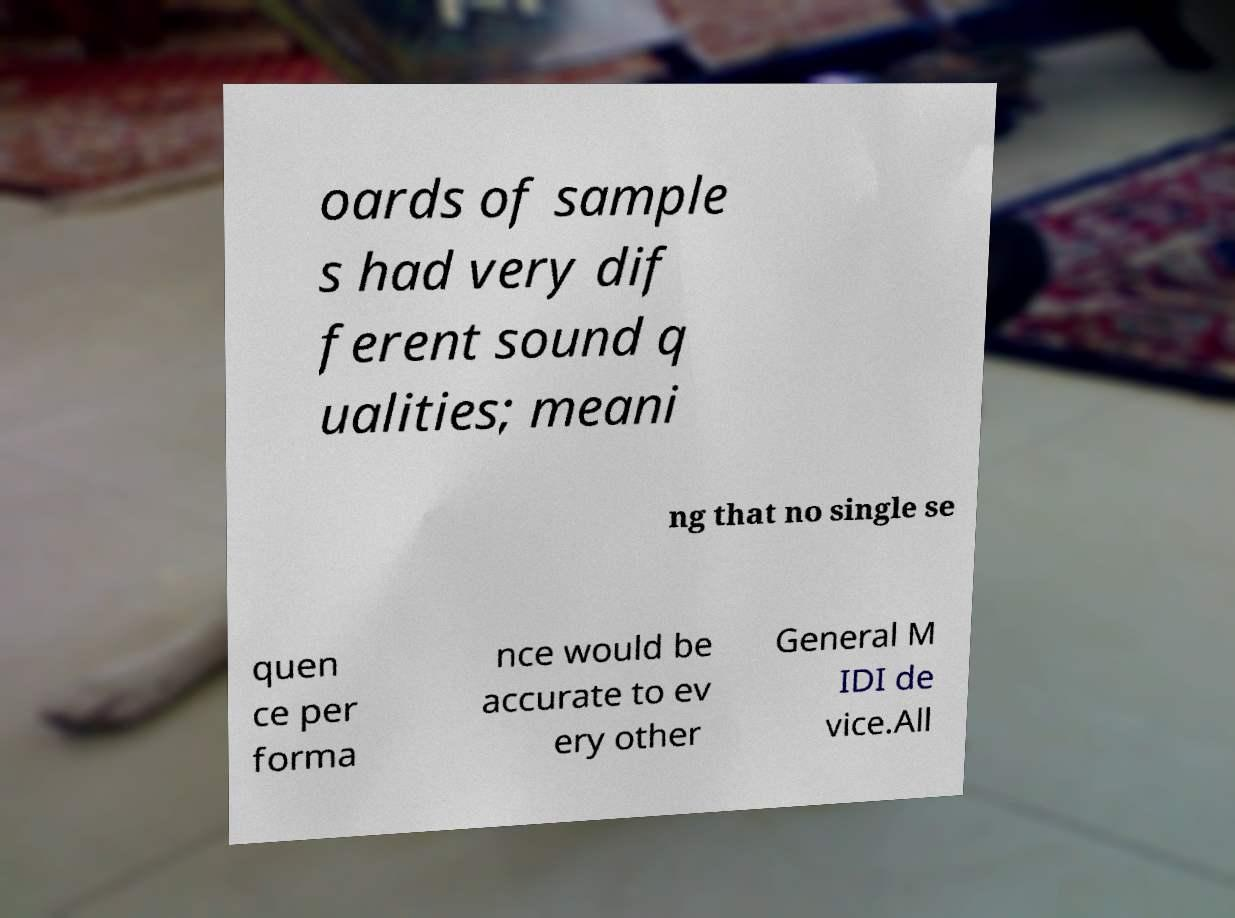I need the written content from this picture converted into text. Can you do that? oards of sample s had very dif ferent sound q ualities; meani ng that no single se quen ce per forma nce would be accurate to ev ery other General M IDI de vice.All 